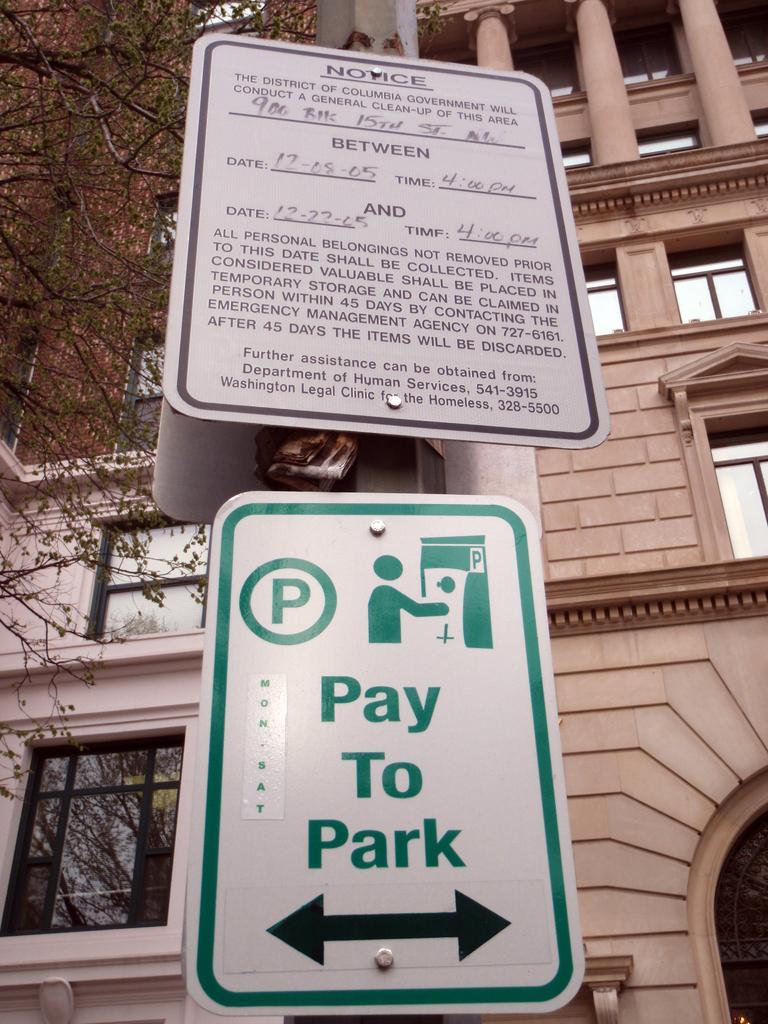What is present on the left side of the image? There is a tree on the left side of the image. What can be seen in the background of the image? There is a building with windows in the background of the image. What is the building in the background characterized by? The building in the background has pillars. What else is present in the image besides the tree and building? There is a sign board and a notice on a pole in the image. How many cakes are displayed on the sign board in the image? There are no cakes displayed on the sign board in the image. What type of match is being played in the image? There is no match being played in the image. 